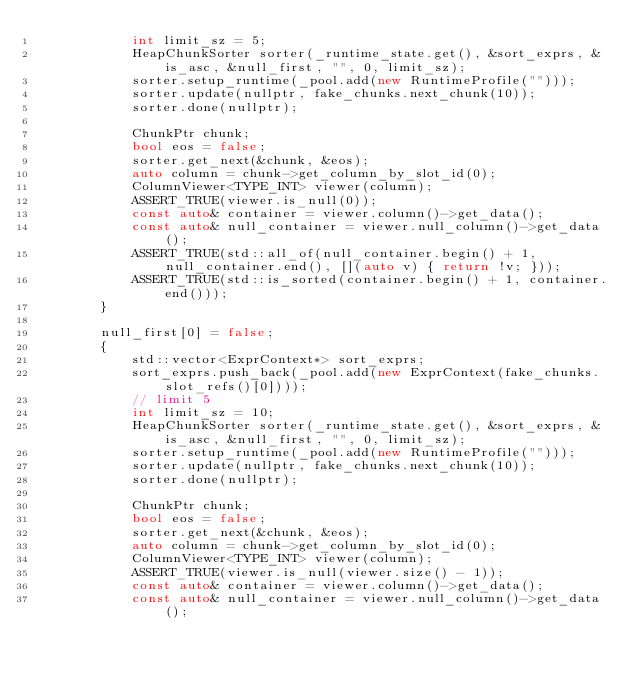<code> <loc_0><loc_0><loc_500><loc_500><_C++_>            int limit_sz = 5;
            HeapChunkSorter sorter(_runtime_state.get(), &sort_exprs, &is_asc, &null_first, "", 0, limit_sz);
            sorter.setup_runtime(_pool.add(new RuntimeProfile("")));
            sorter.update(nullptr, fake_chunks.next_chunk(10));
            sorter.done(nullptr);

            ChunkPtr chunk;
            bool eos = false;
            sorter.get_next(&chunk, &eos);
            auto column = chunk->get_column_by_slot_id(0);
            ColumnViewer<TYPE_INT> viewer(column);
            ASSERT_TRUE(viewer.is_null(0));
            const auto& container = viewer.column()->get_data();
            const auto& null_container = viewer.null_column()->get_data();
            ASSERT_TRUE(std::all_of(null_container.begin() + 1, null_container.end(), [](auto v) { return !v; }));
            ASSERT_TRUE(std::is_sorted(container.begin() + 1, container.end()));
        }

        null_first[0] = false;
        {
            std::vector<ExprContext*> sort_exprs;
            sort_exprs.push_back(_pool.add(new ExprContext(fake_chunks.slot_refs()[0])));
            // limit 5
            int limit_sz = 10;
            HeapChunkSorter sorter(_runtime_state.get(), &sort_exprs, &is_asc, &null_first, "", 0, limit_sz);
            sorter.setup_runtime(_pool.add(new RuntimeProfile("")));
            sorter.update(nullptr, fake_chunks.next_chunk(10));
            sorter.done(nullptr);

            ChunkPtr chunk;
            bool eos = false;
            sorter.get_next(&chunk, &eos);
            auto column = chunk->get_column_by_slot_id(0);
            ColumnViewer<TYPE_INT> viewer(column);
            ASSERT_TRUE(viewer.is_null(viewer.size() - 1));
            const auto& container = viewer.column()->get_data();
            const auto& null_container = viewer.null_column()->get_data();</code> 